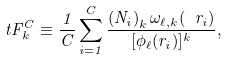Convert formula to latex. <formula><loc_0><loc_0><loc_500><loc_500>\ t F _ { k } ^ { C } \equiv \frac { 1 } { C } \sum _ { i = 1 } ^ { C } \frac { \left ( N _ { i } \right ) _ { k } \omega _ { \ell , k } ( \ r _ { i } ) } { [ \phi _ { \ell } ( r _ { i } ) ] ^ { k } } ,</formula> 